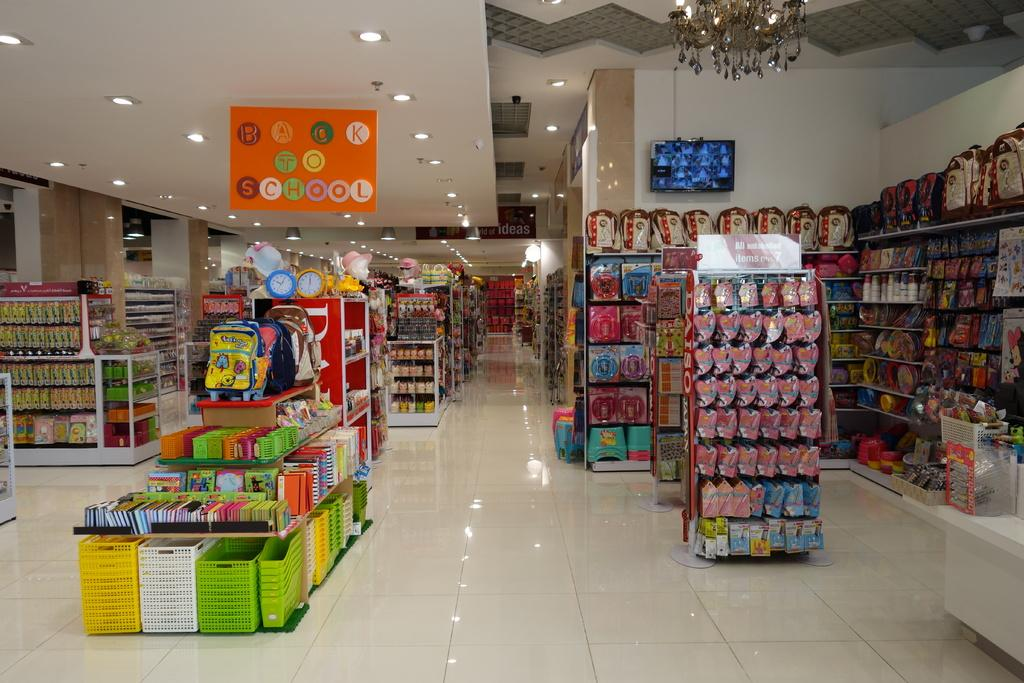<image>
Describe the image concisely. A back to school section is shown in the store 